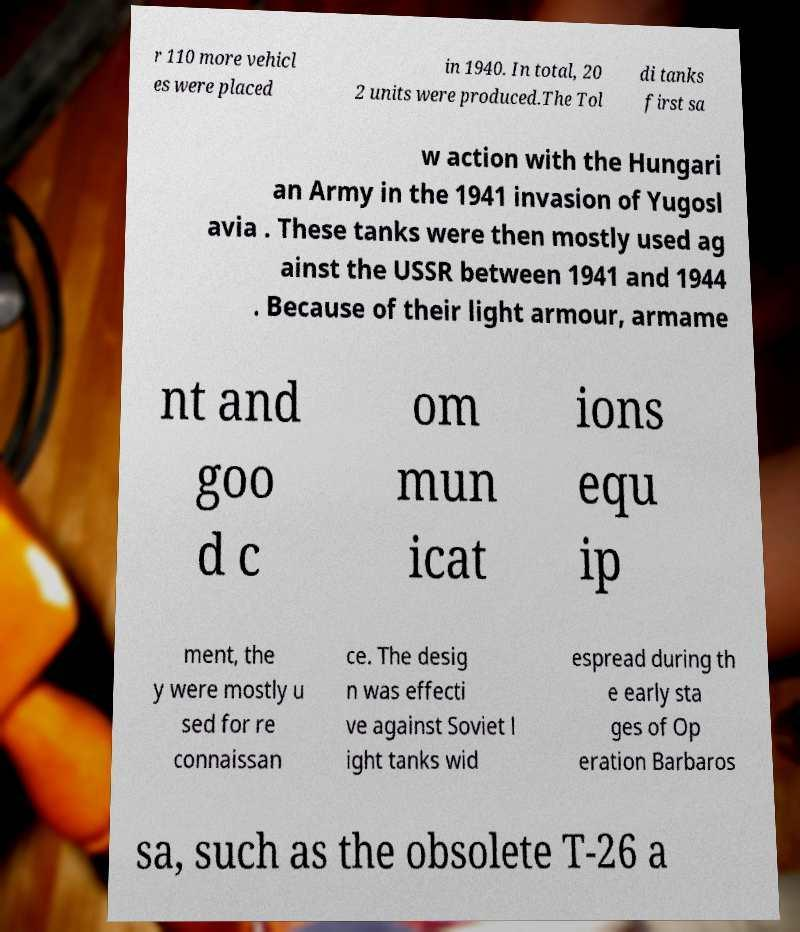Could you assist in decoding the text presented in this image and type it out clearly? r 110 more vehicl es were placed in 1940. In total, 20 2 units were produced.The Tol di tanks first sa w action with the Hungari an Army in the 1941 invasion of Yugosl avia . These tanks were then mostly used ag ainst the USSR between 1941 and 1944 . Because of their light armour, armame nt and goo d c om mun icat ions equ ip ment, the y were mostly u sed for re connaissan ce. The desig n was effecti ve against Soviet l ight tanks wid espread during th e early sta ges of Op eration Barbaros sa, such as the obsolete T-26 a 